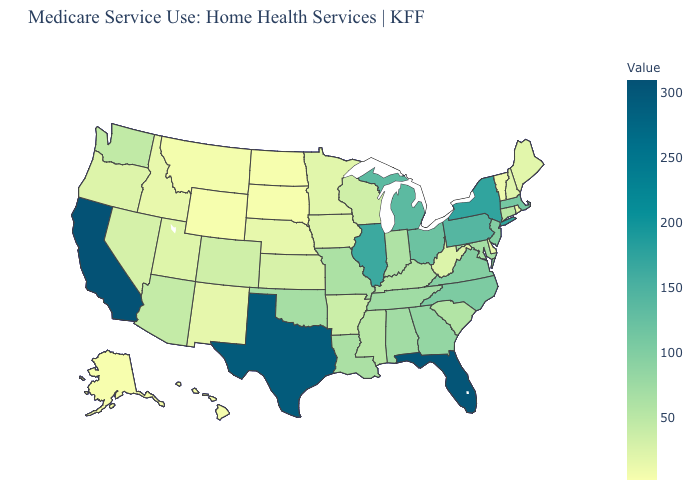Among the states that border Idaho , which have the highest value?
Concise answer only. Washington. Which states hav the highest value in the West?
Short answer required. California. Does California have the highest value in the USA?
Quick response, please. Yes. Among the states that border Nevada , which have the lowest value?
Keep it brief. Idaho. 